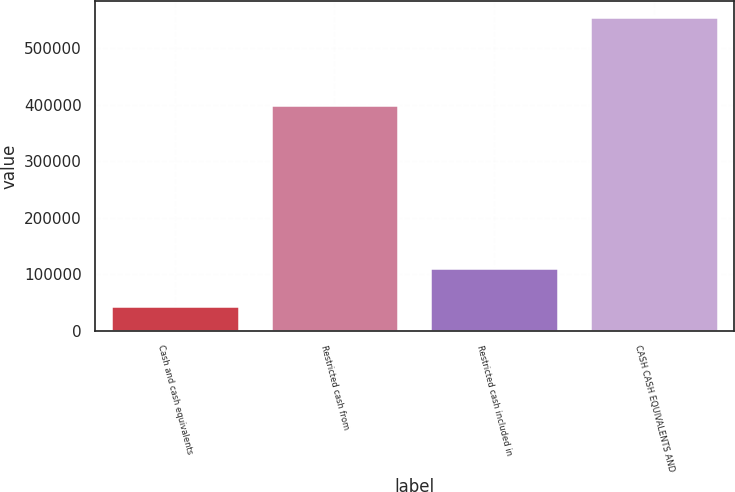<chart> <loc_0><loc_0><loc_500><loc_500><bar_chart><fcel>Cash and cash equivalents<fcel>Restricted cash from<fcel>Restricted cash included in<fcel>CASH CASH EQUIVALENTS AND<nl><fcel>44525<fcel>399442<fcel>110931<fcel>554898<nl></chart> 